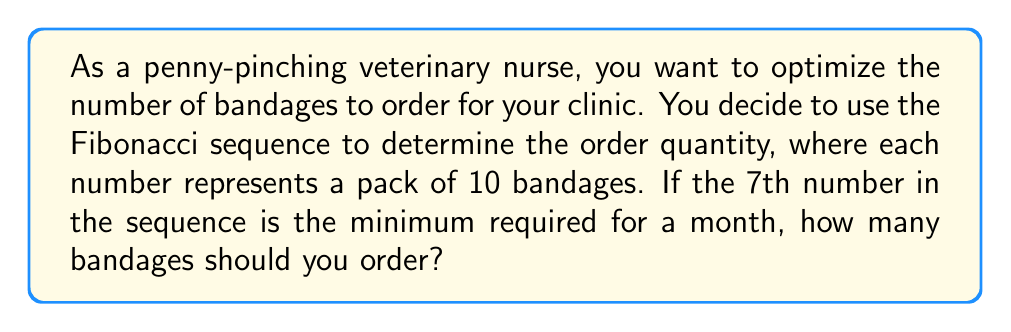Can you solve this math problem? Let's approach this step-by-step:

1) First, recall the Fibonacci sequence. It starts with 0 and 1, and each subsequent number is the sum of the two preceding ones:

   $F_n = F_{n-1} + F_{n-2}$

2) Let's calculate the first 7 numbers in the sequence:

   $F_1 = 0$
   $F_2 = 1$
   $F_3 = F_2 + F_1 = 1 + 0 = 1$
   $F_4 = F_3 + F_2 = 1 + 1 = 2$
   $F_5 = F_4 + F_3 = 2 + 1 = 3$
   $F_6 = F_5 + F_4 = 3 + 2 = 5$
   $F_7 = F_6 + F_5 = 5 + 3 = 8$

3) The 7th number in the sequence is 8.

4) Remember, each number represents a pack of 10 bandages.

5) Therefore, the number of bandages to order is:

   $8 \times 10 = 80$

Thus, as a penny-pinching veterinary nurse, you should order 80 bandages to meet the minimum monthly requirement while optimizing your inventory.
Answer: 80 bandages 